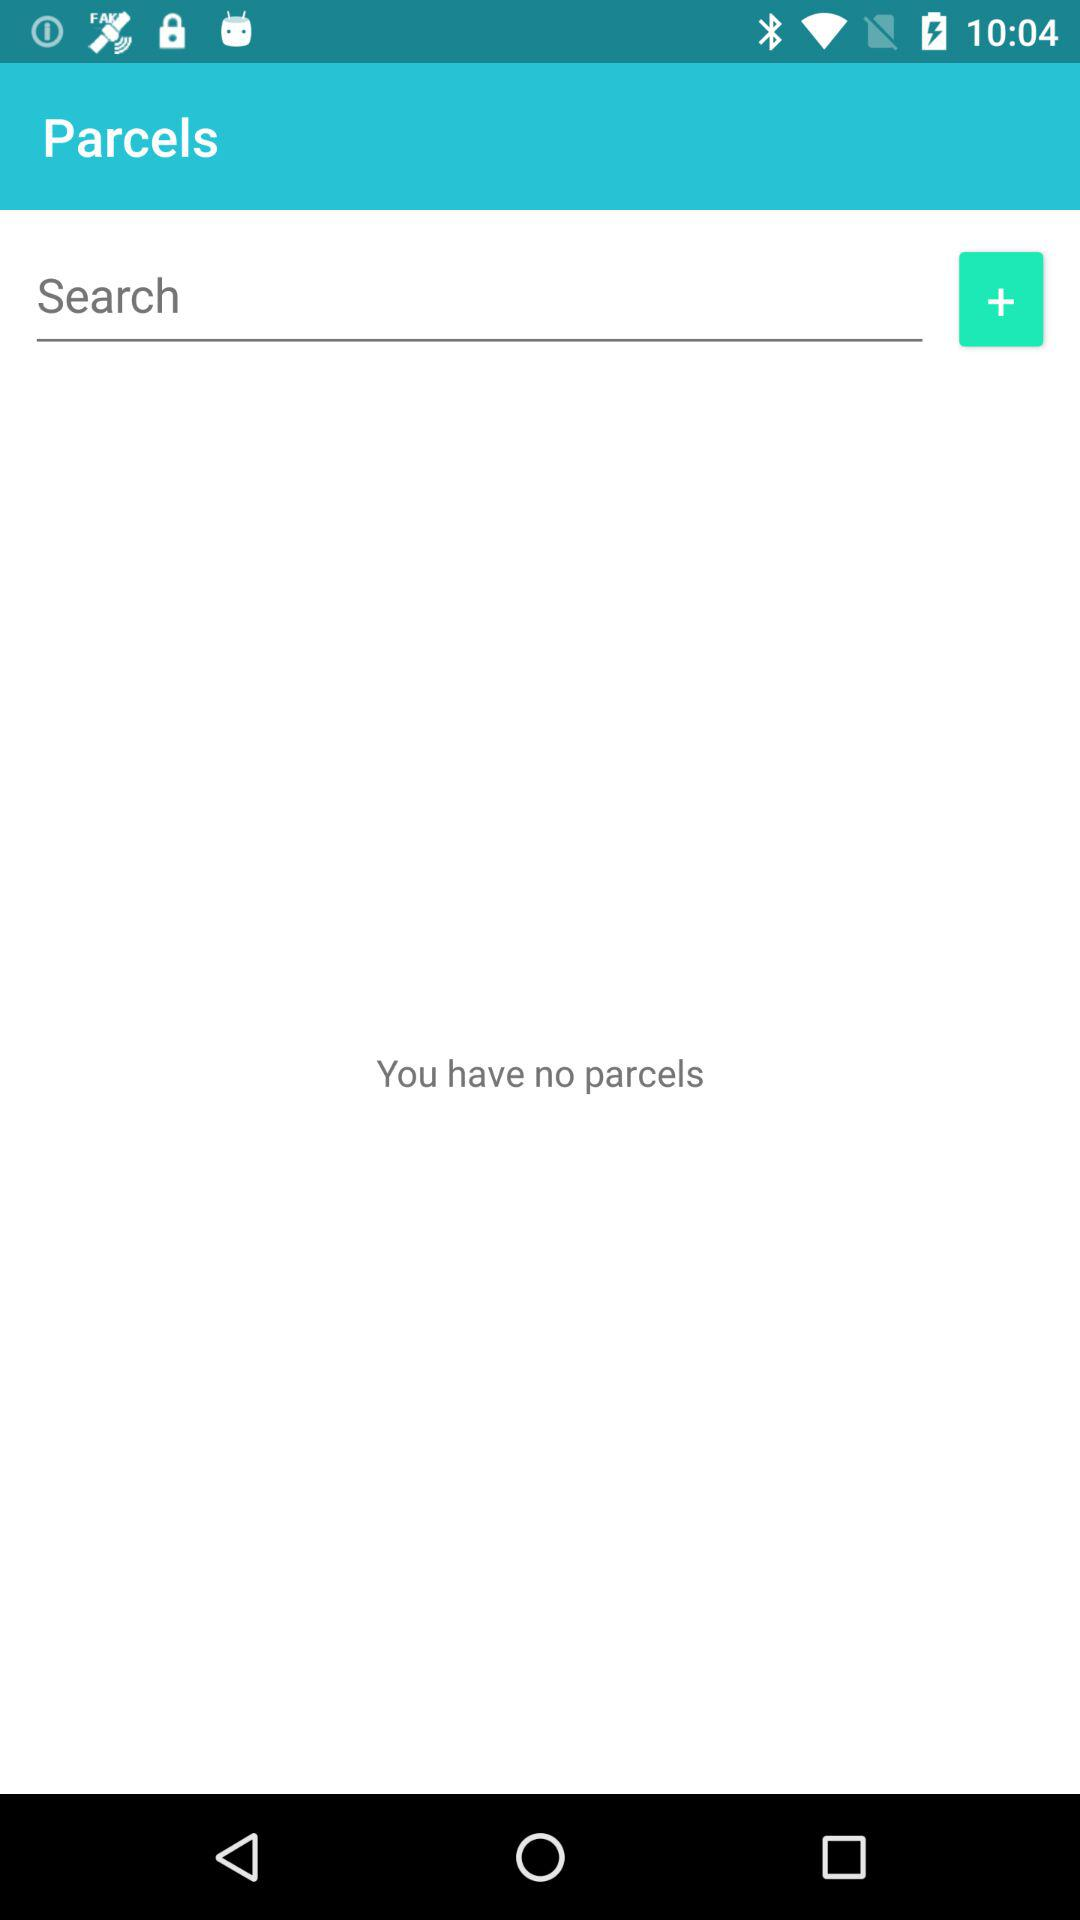Are there any parcels? There are no parcels. 